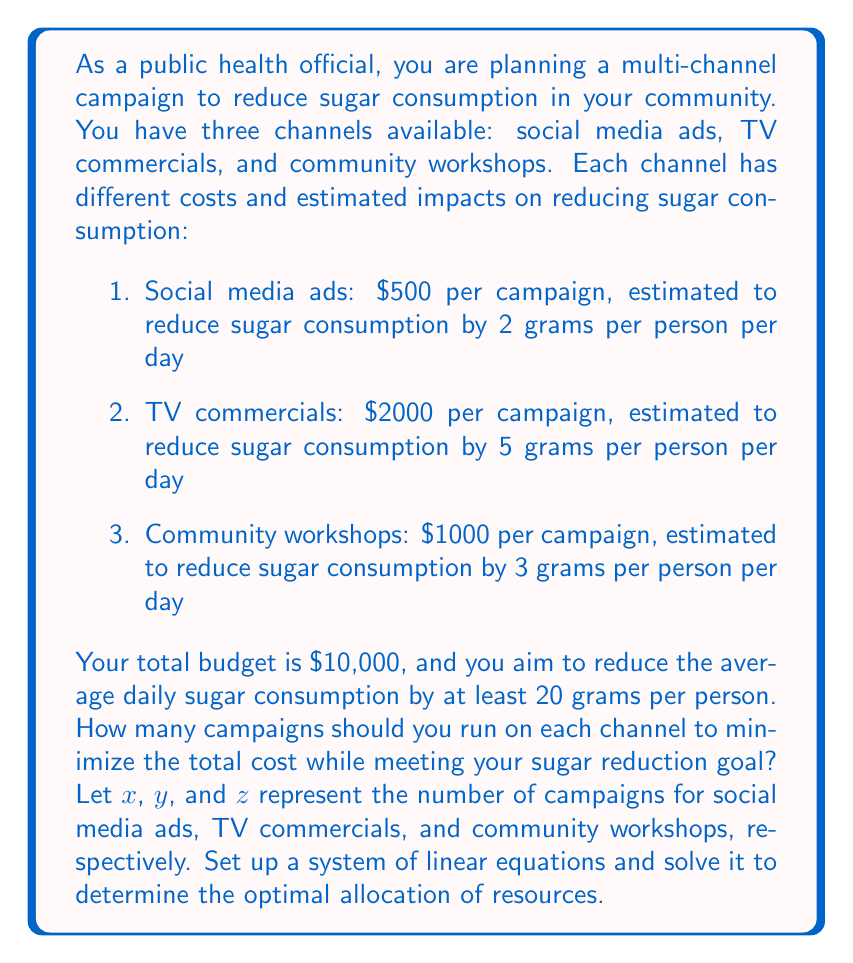Solve this math problem. To solve this problem, we need to set up a system of linear equations based on the given constraints and objective. Let's break it down step by step:

1. Budget constraint:
   The total cost should not exceed $10,000
   $$500x + 2000y + 1000z \leq 10000$$

2. Sugar reduction goal:
   The total reduction should be at least 20 grams per person per day
   $$2x + 5y + 3z \geq 20$$

3. Non-negativity constraints:
   The number of campaigns for each channel cannot be negative
   $$x \geq 0, y \geq 0, z \geq 0$$

Our objective is to minimize the total cost while meeting these constraints. We can set up the objective function as:

$$\text{Minimize: } 500x + 2000y + 1000z$$

To solve this linear programming problem, we can use the simplex method or a graphical approach. However, given the integer nature of the variables (we can't have fractional campaigns), we need to use integer programming techniques.

One approach is to solve the relaxed linear programming problem and then round the solution to the nearest integers. Using a linear programming solver, we get the following solution:

$$x = 0, y = 4, z = 0$$

This solution suggests running 4 TV commercial campaigns, which would cost $8,000 and reduce sugar consumption by 20 grams per person per day, meeting both our budget and reduction goals.

To verify if this is the optimal integer solution, we can check nearby integer combinations:

1. 3 TV commercials and 2 social media ads:
   Cost: $3000 + $1000 = $7000
   Reduction: 15 + 4 = 19 grams (doesn't meet the goal)

2. 4 TV commercials and 1 social media ad:
   Cost: $8000 + $500 = $8500
   Reduction: 20 + 2 = 22 grams (meets the goal, but costs more)

3. 3 TV commercials and 1 community workshop:
   Cost: $6000 + $1000 = $7000
   Reduction: 15 + 3 = 18 grams (doesn't meet the goal)

Therefore, the optimal integer solution is to run 4 TV commercial campaigns.
Answer: The optimal allocation of resources is to run 4 TV commercial campaigns, which will cost $8,000 and reduce sugar consumption by 20 grams per person per day. This solution can be represented as:

$$x = 0, y = 4, z = 0$$

where $x$, $y$, and $z$ represent the number of campaigns for social media ads, TV commercials, and community workshops, respectively. 